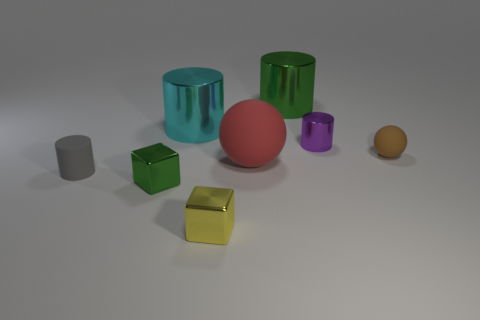There is a small metallic object that is both in front of the tiny metallic cylinder and on the right side of the tiny green metallic object; what is its color?
Keep it short and to the point. Yellow. Are there any spheres that have the same material as the small green object?
Your response must be concise. No. What is the size of the gray matte cylinder?
Make the answer very short. Small. What is the size of the ball that is to the left of the small metal object that is behind the small brown ball?
Your answer should be very brief. Large. There is a yellow thing that is the same shape as the tiny green metallic thing; what is it made of?
Ensure brevity in your answer.  Metal. How many big objects are there?
Give a very brief answer. 3. The matte ball right of the green object behind the tiny metallic thing right of the green metal cylinder is what color?
Ensure brevity in your answer.  Brown. Is the number of yellow metallic cubes less than the number of large gray cubes?
Keep it short and to the point. No. There is a tiny rubber thing that is the same shape as the purple metallic object; what is its color?
Keep it short and to the point. Gray. What color is the small sphere that is the same material as the large sphere?
Ensure brevity in your answer.  Brown. 